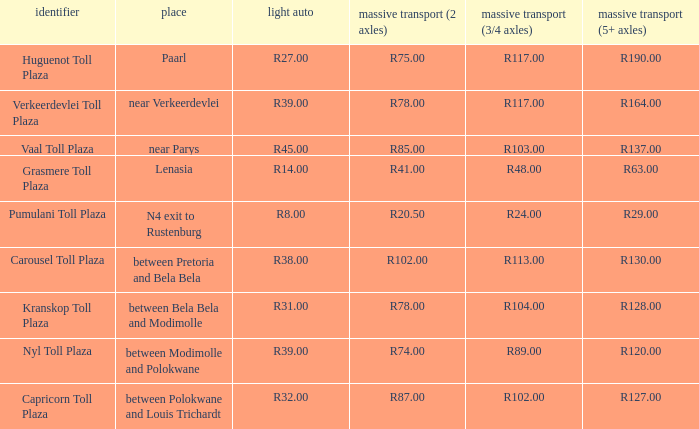What is the location of the Carousel toll plaza? Between pretoria and bela bela. 